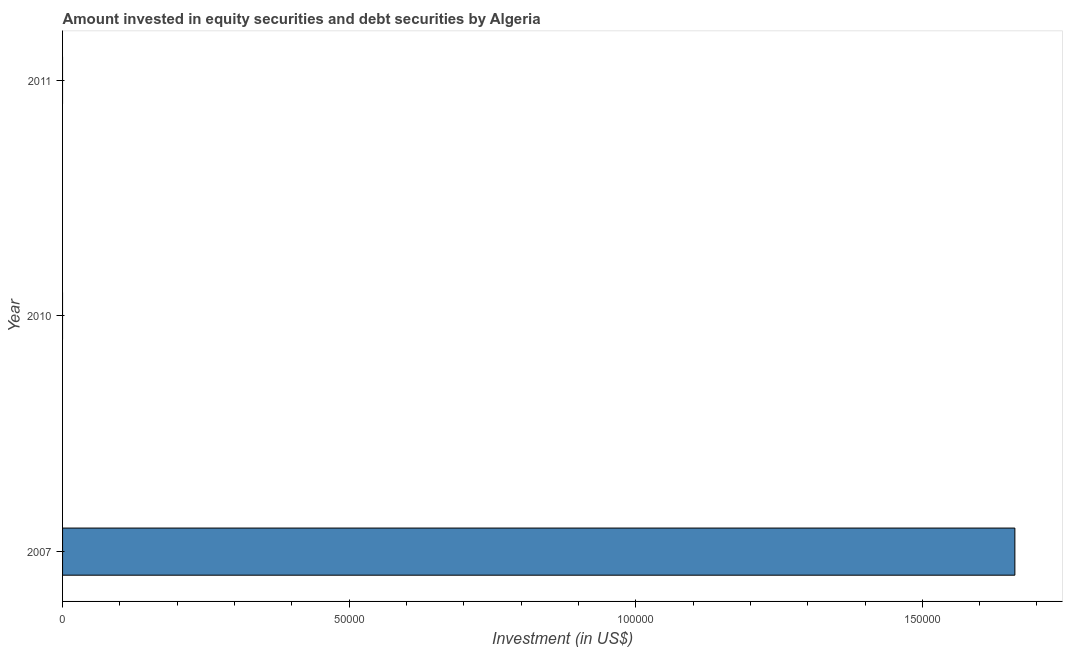Does the graph contain any zero values?
Provide a succinct answer. Yes. What is the title of the graph?
Offer a terse response. Amount invested in equity securities and debt securities by Algeria. What is the label or title of the X-axis?
Your response must be concise. Investment (in US$). What is the label or title of the Y-axis?
Ensure brevity in your answer.  Year. What is the portfolio investment in 2007?
Your response must be concise. 1.66e+05. Across all years, what is the maximum portfolio investment?
Keep it short and to the point. 1.66e+05. In which year was the portfolio investment maximum?
Your response must be concise. 2007. What is the sum of the portfolio investment?
Ensure brevity in your answer.  1.66e+05. What is the average portfolio investment per year?
Offer a terse response. 5.54e+04. In how many years, is the portfolio investment greater than 120000 US$?
Keep it short and to the point. 1. What is the difference between the highest and the lowest portfolio investment?
Make the answer very short. 1.66e+05. In how many years, is the portfolio investment greater than the average portfolio investment taken over all years?
Give a very brief answer. 1. How many bars are there?
Ensure brevity in your answer.  1. How many years are there in the graph?
Provide a succinct answer. 3. What is the Investment (in US$) of 2007?
Make the answer very short. 1.66e+05. What is the Investment (in US$) in 2010?
Offer a terse response. 0. What is the Investment (in US$) of 2011?
Provide a short and direct response. 0. 